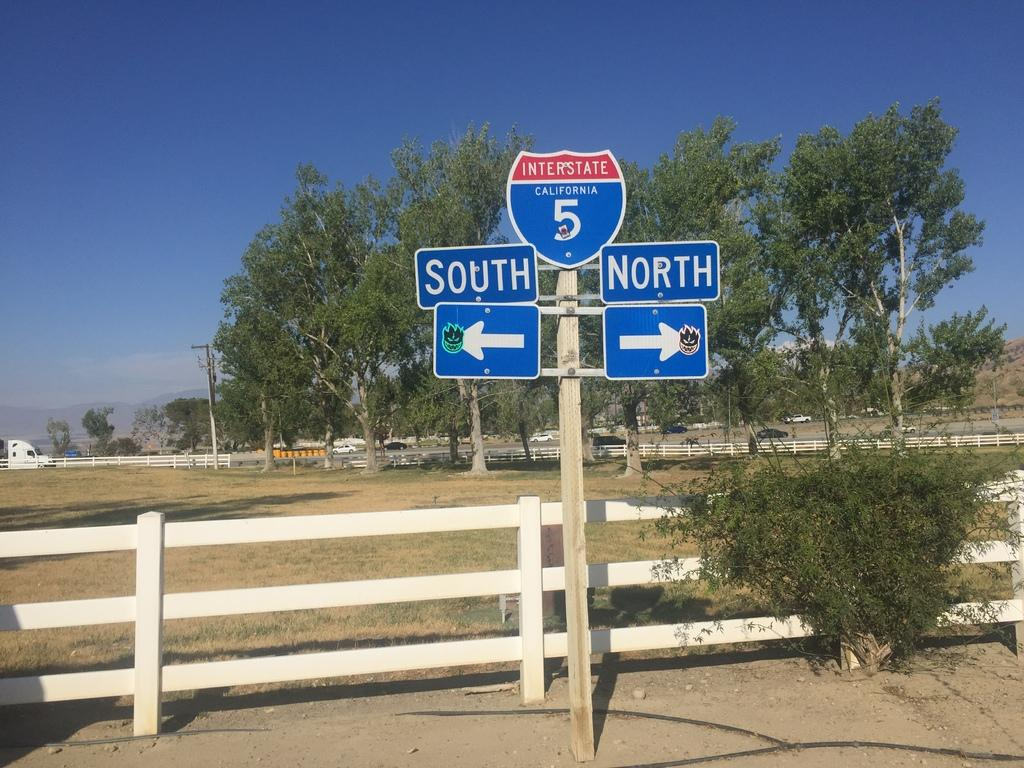<image>
Summarize the visual content of the image. a post that has north and south on it 